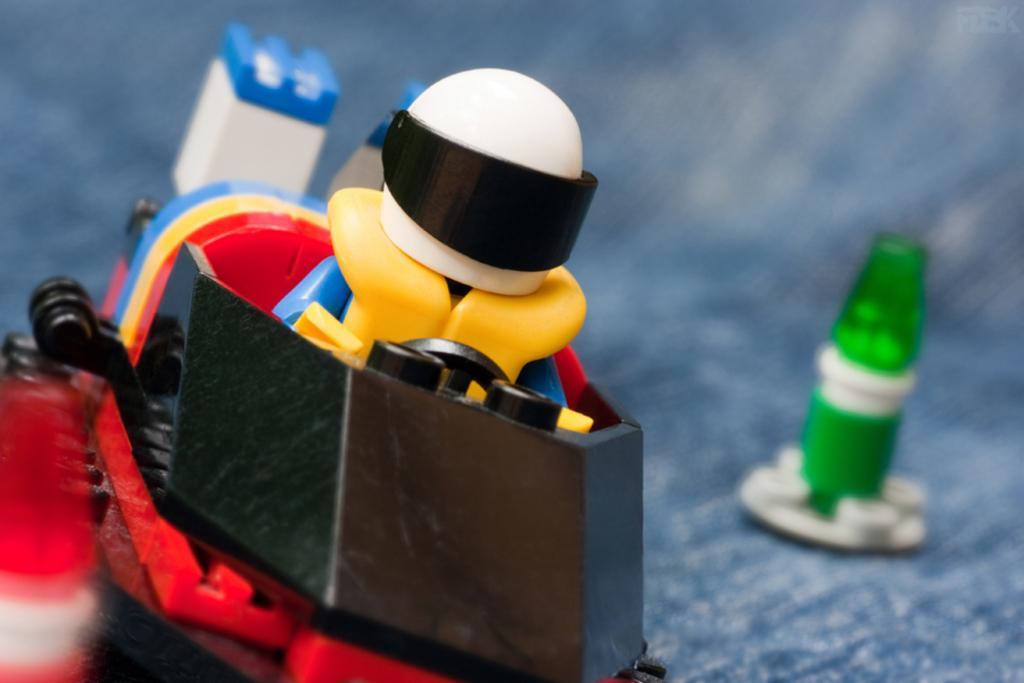Describe this image in one or two sentences. In this image we can see a toy vehicle which is in different colors like yellow, blue, red, white and black and on right side of the image there is another toy. 